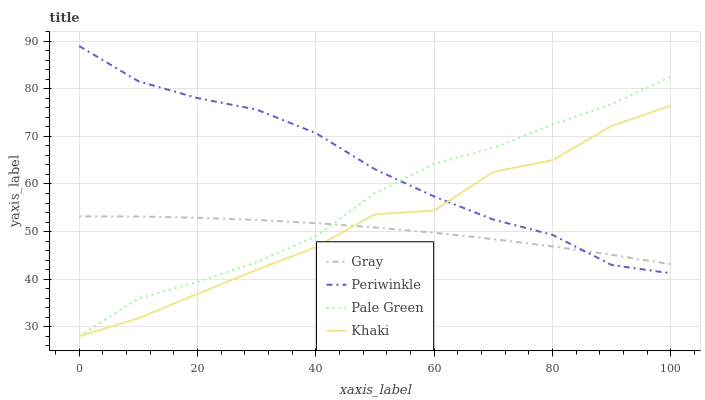Does Pale Green have the minimum area under the curve?
Answer yes or no. No. Does Pale Green have the maximum area under the curve?
Answer yes or no. No. Is Pale Green the smoothest?
Answer yes or no. No. Is Pale Green the roughest?
Answer yes or no. No. Does Periwinkle have the lowest value?
Answer yes or no. No. Does Pale Green have the highest value?
Answer yes or no. No. 